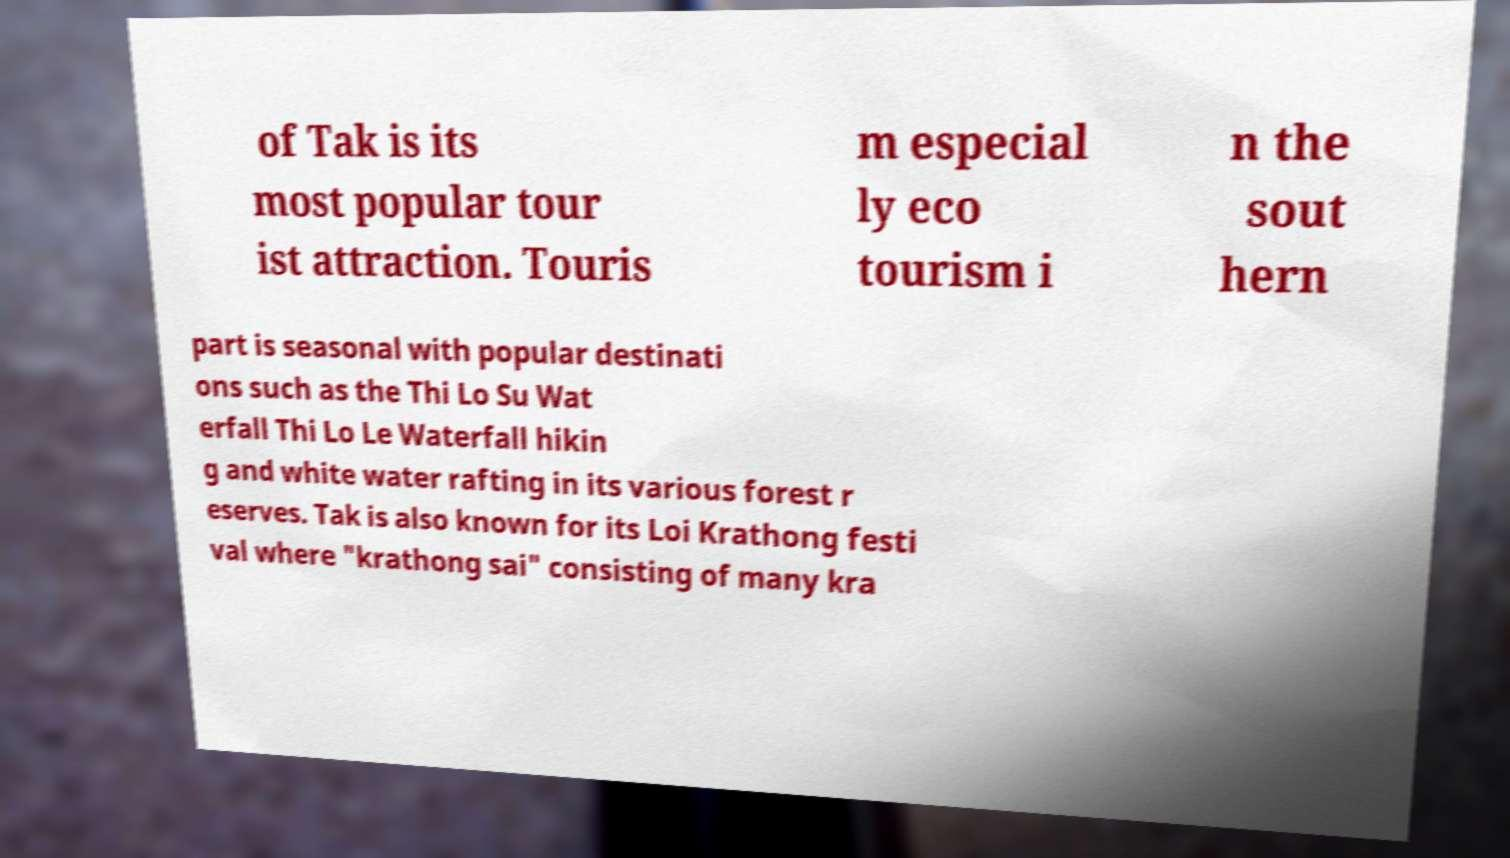Can you accurately transcribe the text from the provided image for me? of Tak is its most popular tour ist attraction. Touris m especial ly eco tourism i n the sout hern part is seasonal with popular destinati ons such as the Thi Lo Su Wat erfall Thi Lo Le Waterfall hikin g and white water rafting in its various forest r eserves. Tak is also known for its Loi Krathong festi val where "krathong sai" consisting of many kra 